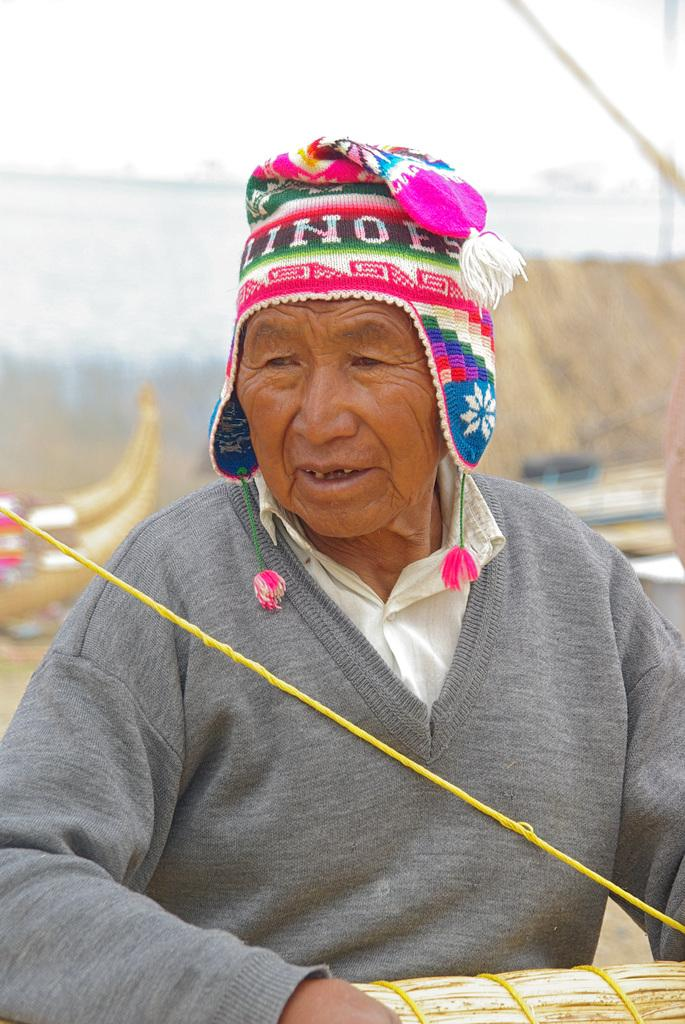What is the main subject of the image? There is a person in the image. What is the person wearing in the image? The person is wearing a gray dress and a cap with blue, pink, and white colors. What can be seen in the background of the image? The background of the image is the sky. What is the color of the sky in the image? The color of the sky in the image is white. What type of ice can be seen melting on the person's shoulder in the image? There is no ice present in the image; the person is wearing a cap and a gray dress. How many pies are visible on the person's lap in the image? There are no pies present in the image; the person is not holding or sitting on any pies. 